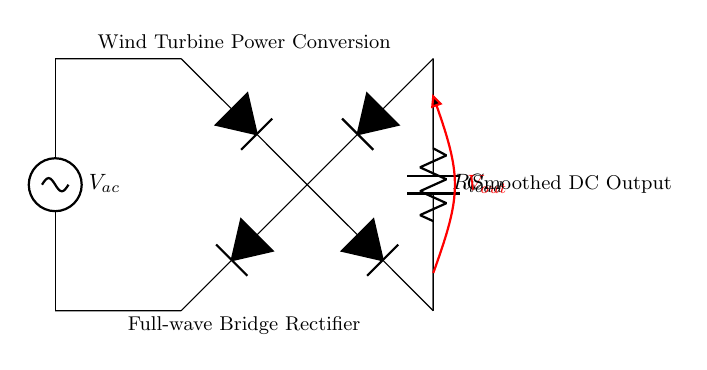What is the source in this circuit? The source represented in this circuit is an AC voltage source, which is typically indicative of the generated electrical power from a wind turbine. It is marked as V_ac in the diagram.
Answer: AC voltage source What type of rectifier is used here? This circuit diagram utilizes a full-wave bridge rectifier, which is indicated by the arrangement of four diodes forming a bridge circuit. This setup allows for both halves of the AC waveform to be used in the conversion process.
Answer: Full-wave bridge rectifier What does the smoothing capacitor do? The smoothing capacitor (C) is used to reduce the fluctuations in the rectified output voltage, providing a more constant DC voltage to the load. It smooths out the ripples caused by the rectification process.
Answer: Reduces voltage fluctuations What is the purpose of the load resistor? The load resistor (R_load) is the component that consumes the power in the circuit. It represents the electrical load that utilizes the smoothed DC output voltage.
Answer: Power consumption What is the expected output voltage? The output voltage (V_out) is taken across the load resistor and is the DC voltage provided after rectification and smoothing. As shown in the circuit, it is marked distinctly, implying it is the desired voltage for further use.
Answer: V_out What happens if the capacitor is removed from this circuit? If the smoothing capacitor is removed, the output voltage will exhibit significant fluctuations (ripples) corresponding to the AC input rather than providing a smooth DC output, which can be detrimental for many applications.
Answer: Significant voltage fluctuations How many diodes are in the bridge rectifier? The bridge rectifier is composed of four diodes, which are arranged in a specific configuration to achieve full-wave rectification of the AC input.
Answer: Four diodes 